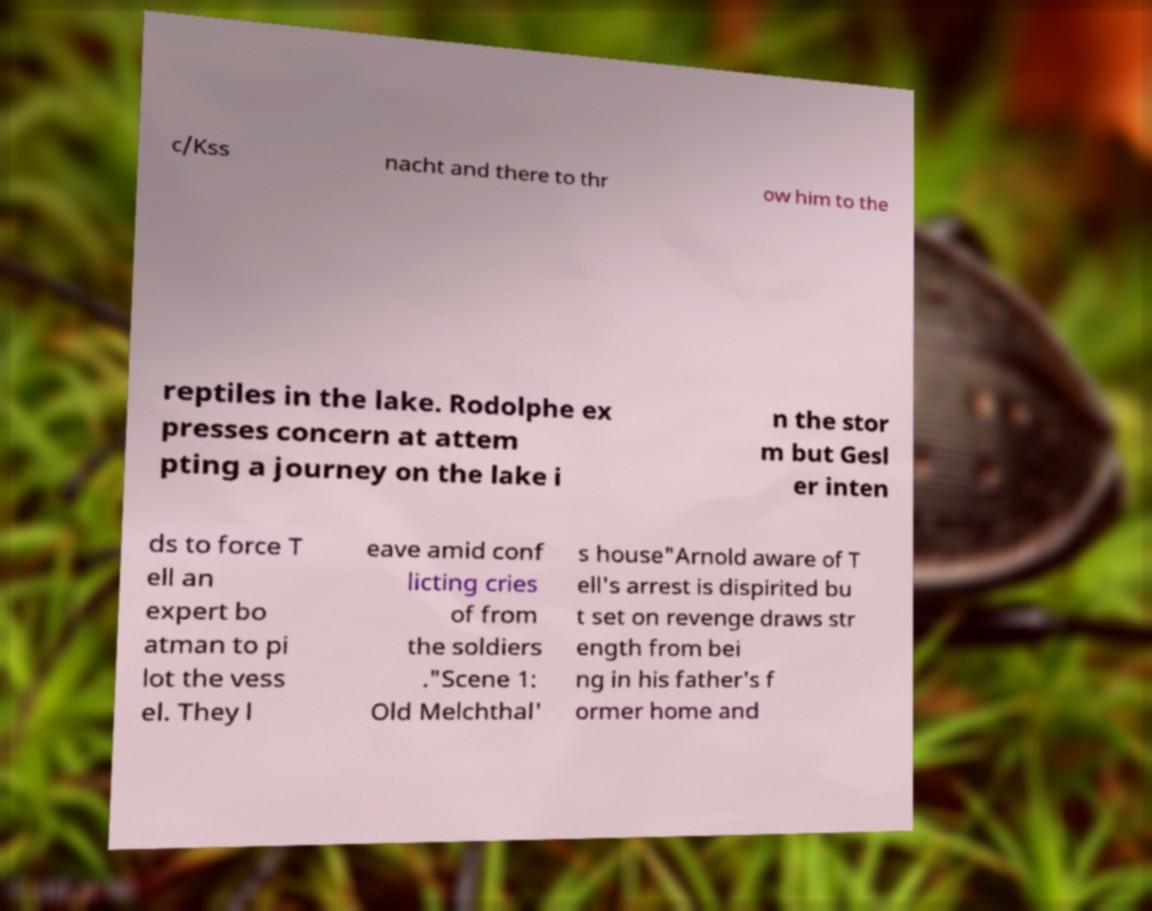Please identify and transcribe the text found in this image. c/Kss nacht and there to thr ow him to the reptiles in the lake. Rodolphe ex presses concern at attem pting a journey on the lake i n the stor m but Gesl er inten ds to force T ell an expert bo atman to pi lot the vess el. They l eave amid conf licting cries of from the soldiers ."Scene 1: Old Melchthal' s house"Arnold aware of T ell's arrest is dispirited bu t set on revenge draws str ength from bei ng in his father's f ormer home and 